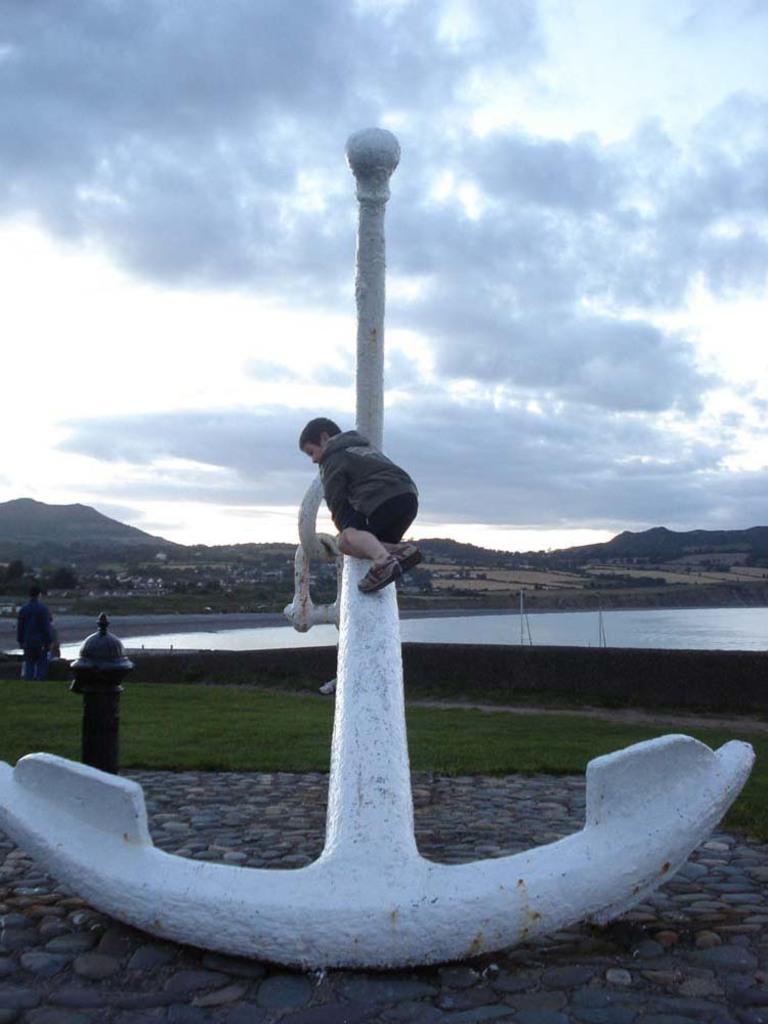Describe this image in one or two sentences. In this image I can see people, a fire hydrant, white color object, the grass and other objects on the ground. In the background I can see the water, mountains, trees and the sky. 